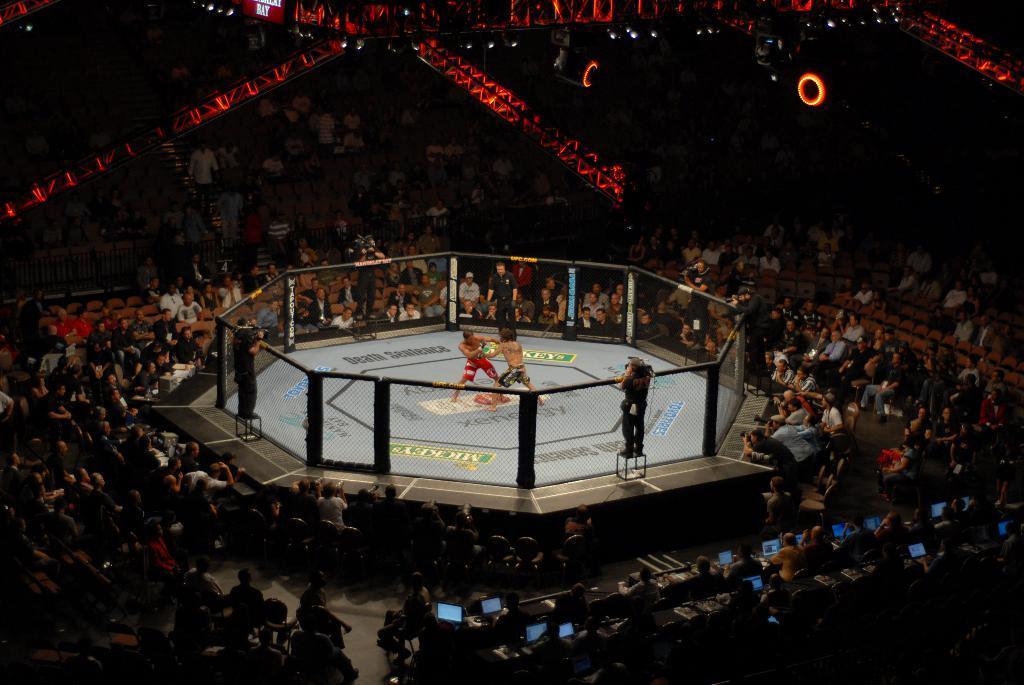Can you describe this image briefly? In this image there is a fighting ring in the middle in which there are two players fighting each other. In the background there are so many spectators who are watching the game. At the top there are lights. There is a fence around the ring and there are few people standing on the stool in four directions around the ring. At the bottom there are few people working with the laptops. 